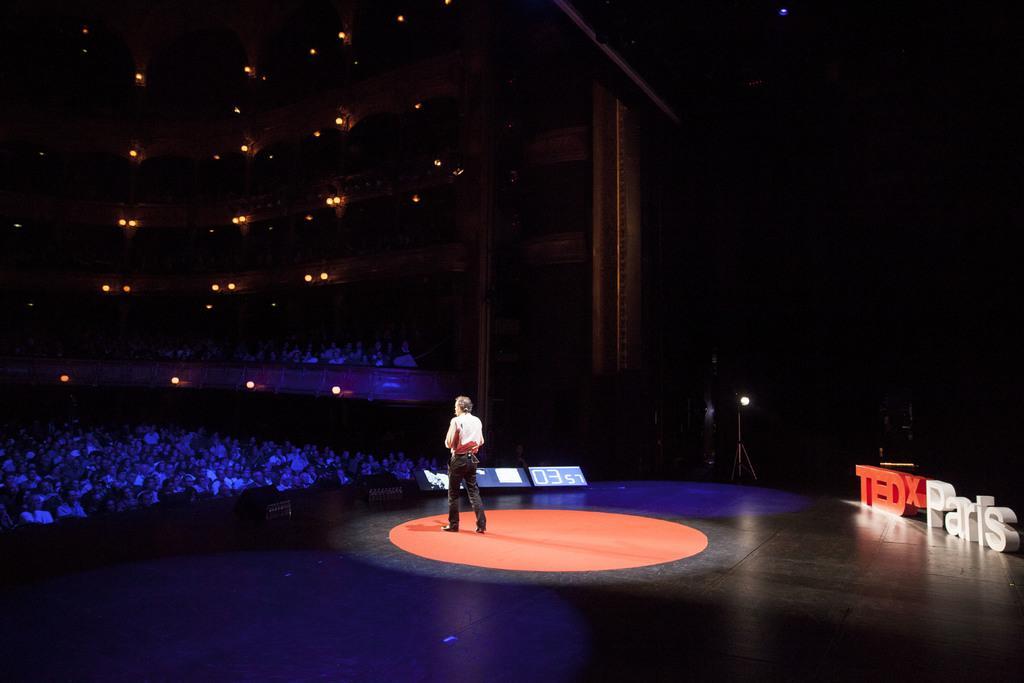Could you give a brief overview of what you see in this image? In the center of the image we can see a man standing on the stage. On the left there are people sitting. At the top there are lights. 